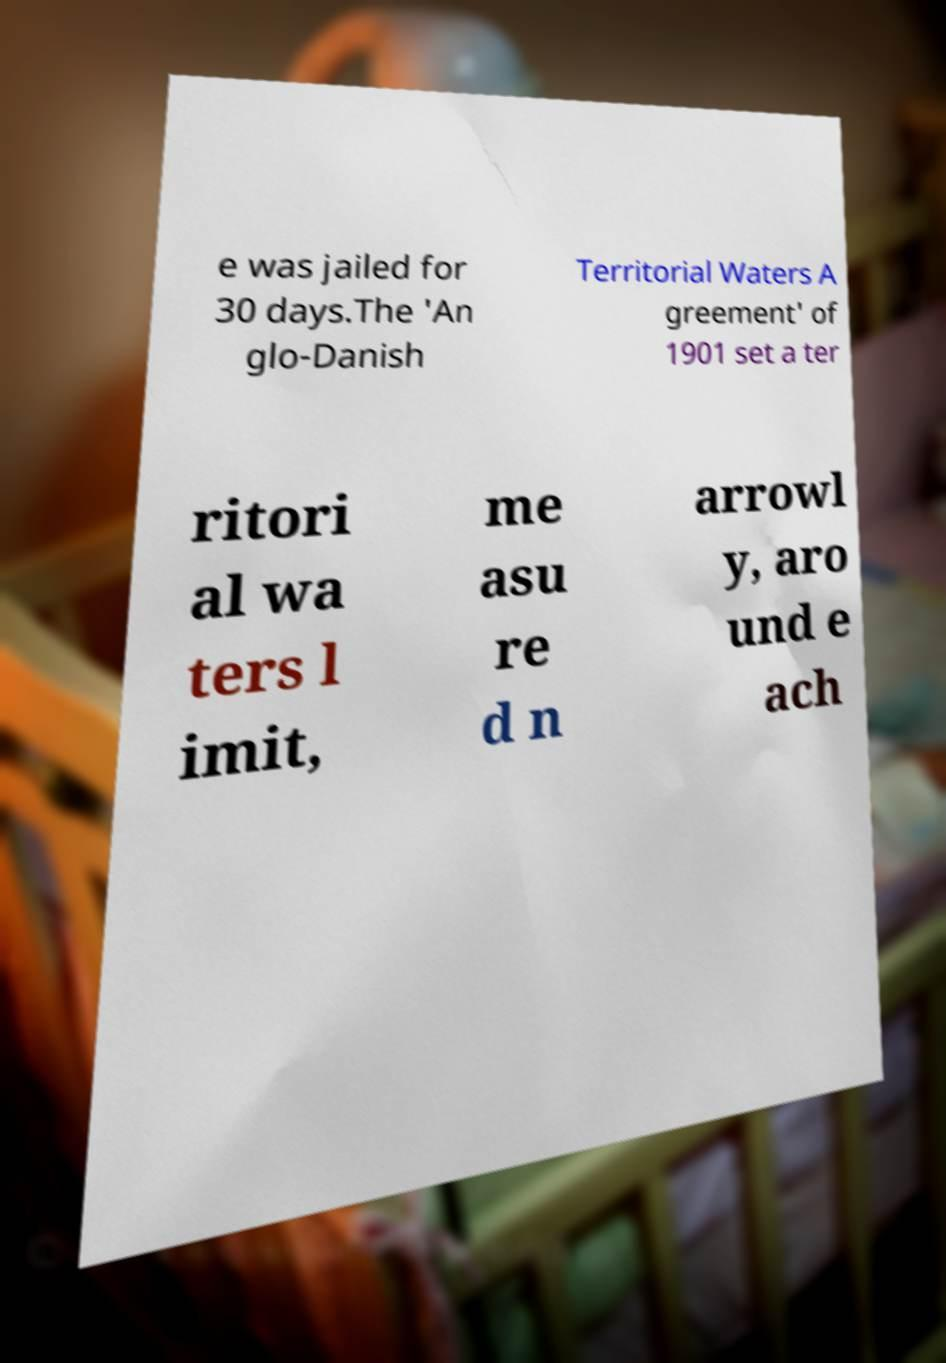I need the written content from this picture converted into text. Can you do that? e was jailed for 30 days.The 'An glo-Danish Territorial Waters A greement' of 1901 set a ter ritori al wa ters l imit, me asu re d n arrowl y, aro und e ach 